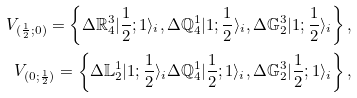<formula> <loc_0><loc_0><loc_500><loc_500>V _ { ( \frac { 1 } { 2 } ; 0 ) } = \left \{ \Delta \mathbb { R } ^ { 3 } _ { 4 } | { \frac { 1 } { 2 } } ; 1 \rangle _ { i } , \Delta \mathbb { Q } ^ { 1 } _ { 4 } | 1 ; { \frac { 1 } { 2 } } \rangle _ { i } , \Delta \mathbb { G } ^ { 3 } _ { 2 } | 1 ; { \frac { 1 } { 2 } } \rangle _ { i } \right \} , \\ V _ { ( 0 ; \frac { 1 } { 2 } ) } = \left \{ \Delta \mathbb { L } ^ { 1 } _ { 2 } | 1 ; { \frac { 1 } { 2 } } \rangle _ { i } \Delta \mathbb { Q } ^ { 1 } _ { 4 } | { \frac { 1 } { 2 } } ; 1 \rangle _ { i } , \Delta \mathbb { G } ^ { 3 } _ { 2 } | { \frac { 1 } { 2 } } ; 1 \rangle _ { i } \right \} ,</formula> 